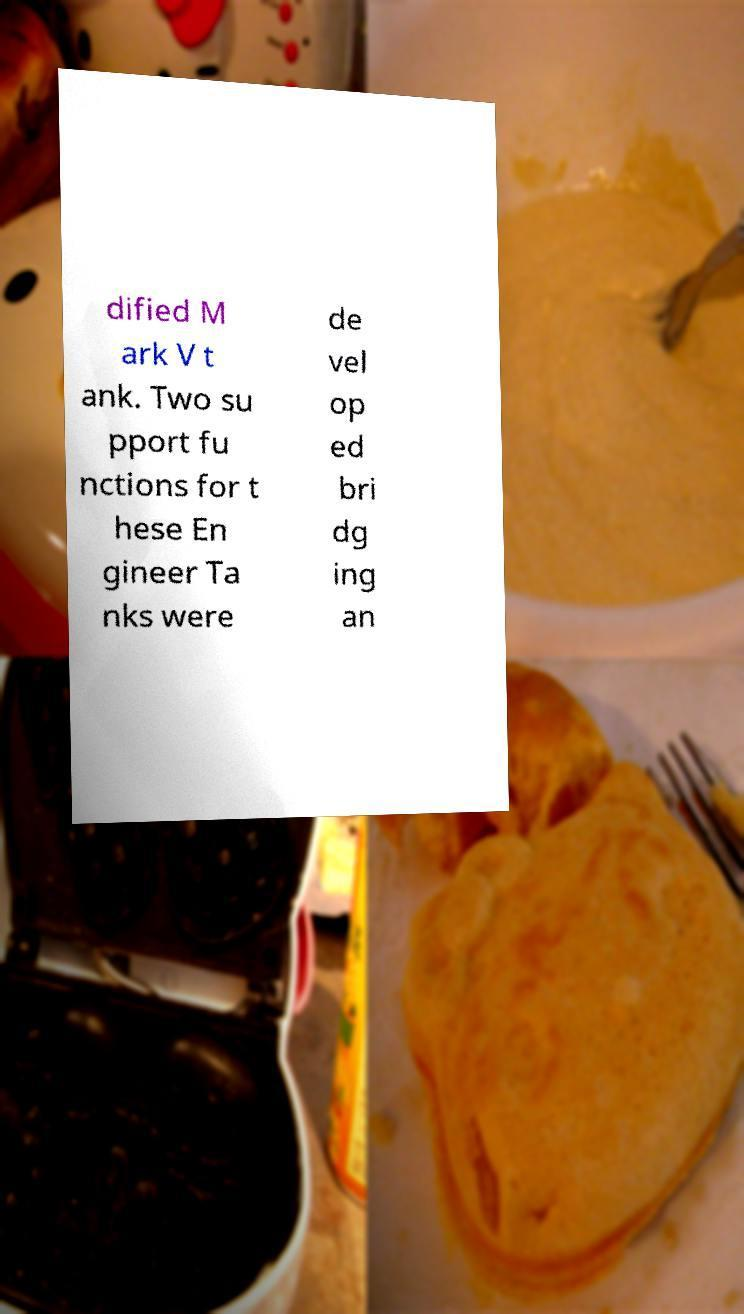Could you extract and type out the text from this image? dified M ark V t ank. Two su pport fu nctions for t hese En gineer Ta nks were de vel op ed bri dg ing an 